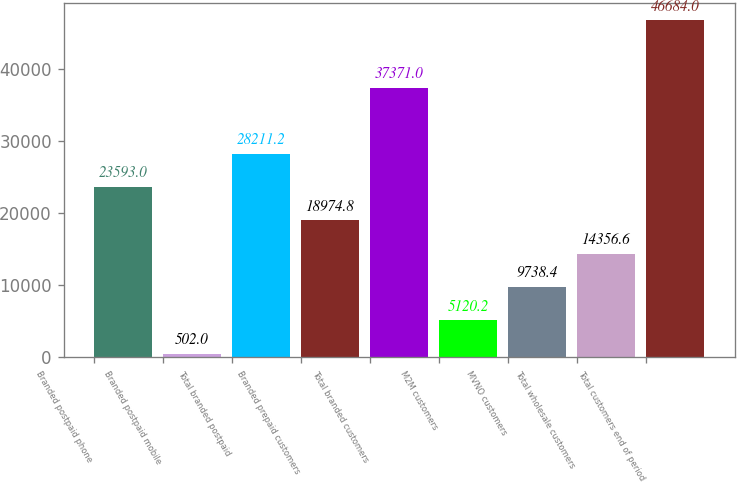<chart> <loc_0><loc_0><loc_500><loc_500><bar_chart><fcel>Branded postpaid phone<fcel>Branded postpaid mobile<fcel>Total branded postpaid<fcel>Branded prepaid customers<fcel>Total branded customers<fcel>M2M customers<fcel>MVNO customers<fcel>Total wholesale customers<fcel>Total customers end of period<nl><fcel>23593<fcel>502<fcel>28211.2<fcel>18974.8<fcel>37371<fcel>5120.2<fcel>9738.4<fcel>14356.6<fcel>46684<nl></chart> 